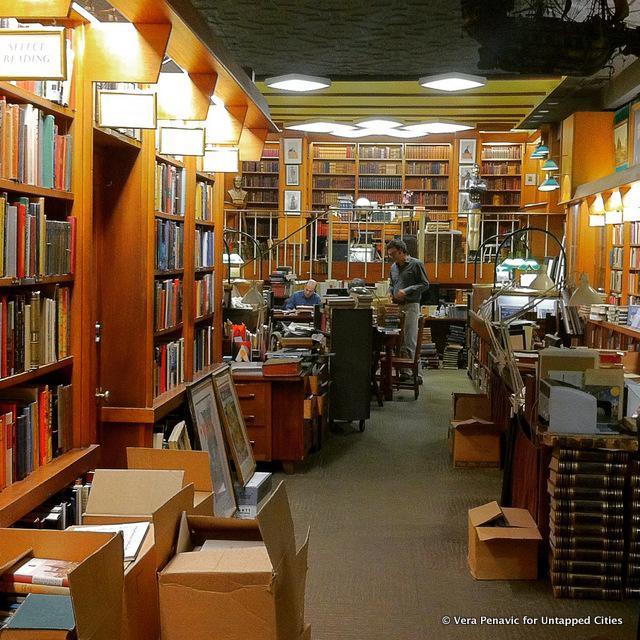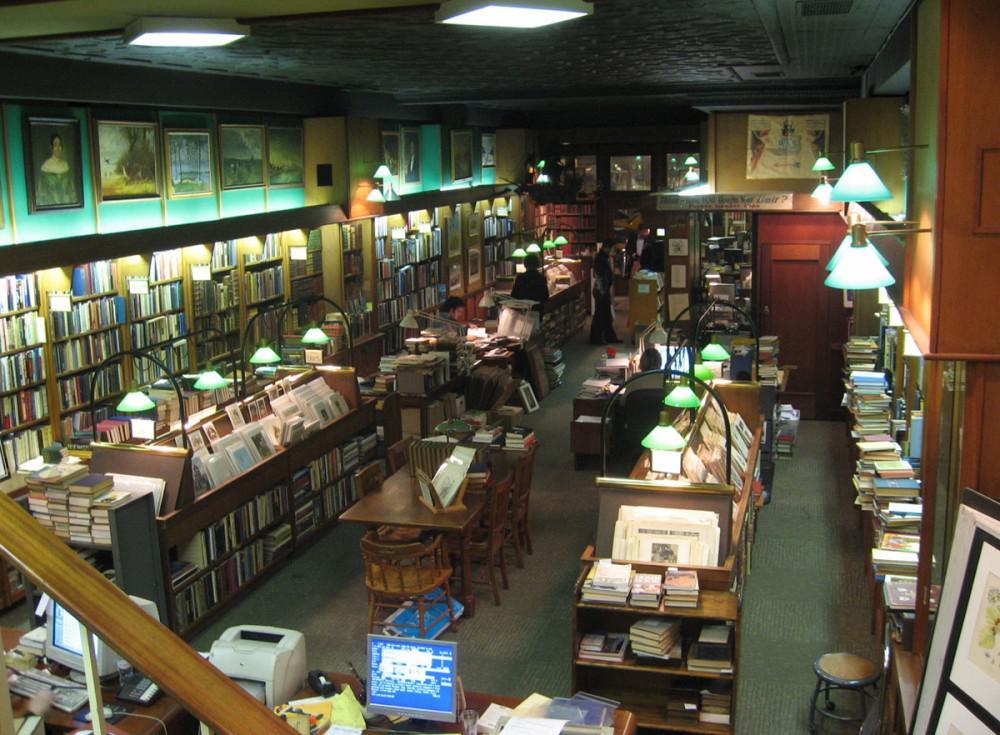The first image is the image on the left, the second image is the image on the right. Evaluate the accuracy of this statement regarding the images: "The right image includes green reading lamps suspended from black arches.". Is it true? Answer yes or no. Yes. 